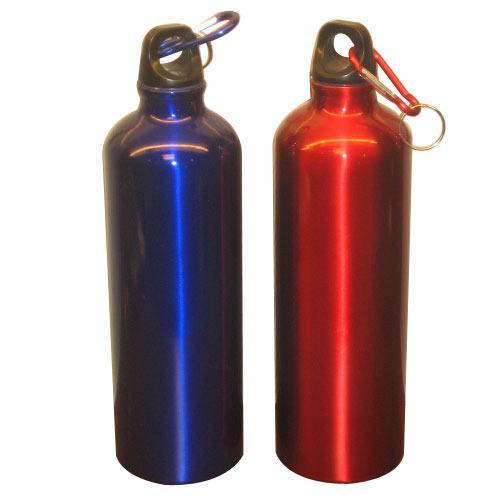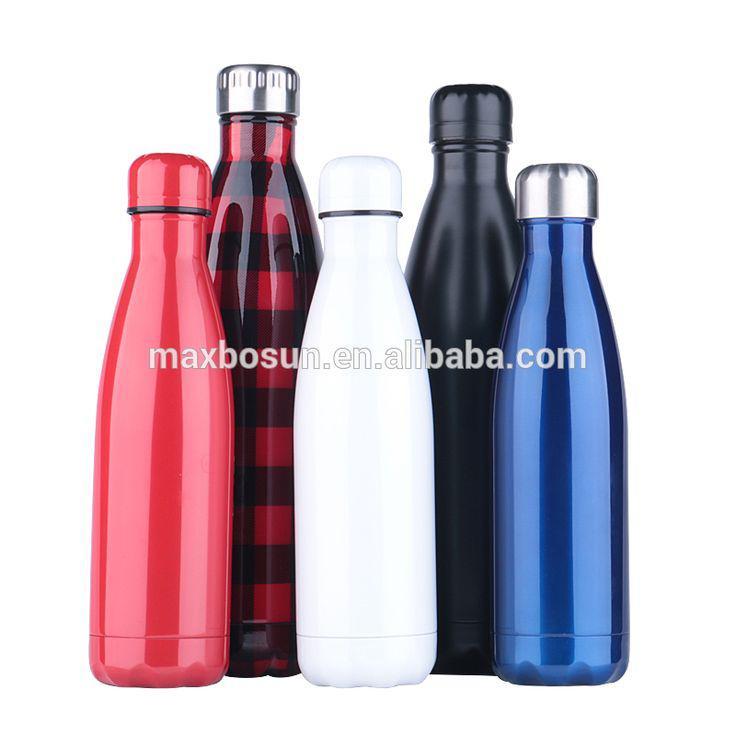The first image is the image on the left, the second image is the image on the right. Examine the images to the left and right. Is the description "There are seven bottles." accurate? Answer yes or no. Yes. 